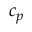Convert formula to latex. <formula><loc_0><loc_0><loc_500><loc_500>c _ { p }</formula> 